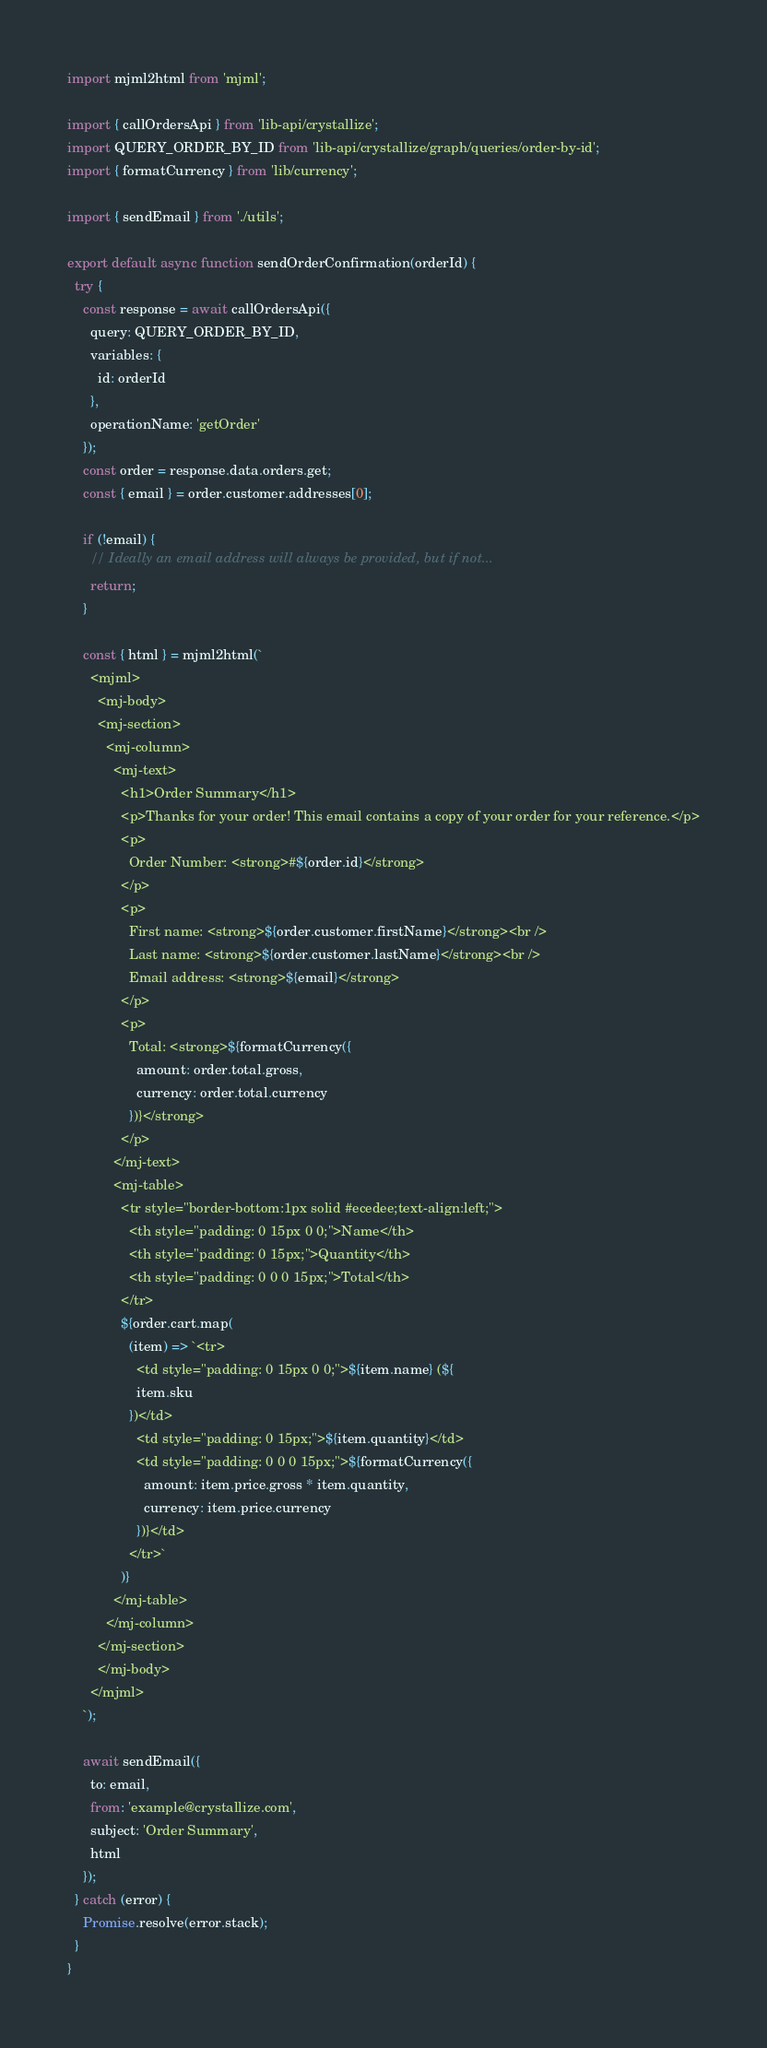Convert code to text. <code><loc_0><loc_0><loc_500><loc_500><_JavaScript_>import mjml2html from 'mjml';

import { callOrdersApi } from 'lib-api/crystallize';
import QUERY_ORDER_BY_ID from 'lib-api/crystallize/graph/queries/order-by-id';
import { formatCurrency } from 'lib/currency';

import { sendEmail } from './utils';

export default async function sendOrderConfirmation(orderId) {
  try {
    const response = await callOrdersApi({
      query: QUERY_ORDER_BY_ID,
      variables: {
        id: orderId
      },
      operationName: 'getOrder'
    });
    const order = response.data.orders.get;
    const { email } = order.customer.addresses[0];

    if (!email) {
      // Ideally an email address will always be provided, but if not...
      return;
    }

    const { html } = mjml2html(`
      <mjml>
        <mj-body>
        <mj-section>
          <mj-column>
            <mj-text>
              <h1>Order Summary</h1>
              <p>Thanks for your order! This email contains a copy of your order for your reference.</p>
              <p>
                Order Number: <strong>#${order.id}</strong>
              </p>
              <p>
                First name: <strong>${order.customer.firstName}</strong><br />
                Last name: <strong>${order.customer.lastName}</strong><br />
                Email address: <strong>${email}</strong>
              </p>
              <p>
                Total: <strong>${formatCurrency({
                  amount: order.total.gross,
                  currency: order.total.currency
                })}</strong>
              </p>
            </mj-text>
            <mj-table>
              <tr style="border-bottom:1px solid #ecedee;text-align:left;">
                <th style="padding: 0 15px 0 0;">Name</th>
                <th style="padding: 0 15px;">Quantity</th>
                <th style="padding: 0 0 0 15px;">Total</th>
              </tr>
              ${order.cart.map(
                (item) => `<tr>
                  <td style="padding: 0 15px 0 0;">${item.name} (${
                  item.sku
                })</td>
                  <td style="padding: 0 15px;">${item.quantity}</td>
                  <td style="padding: 0 0 0 15px;">${formatCurrency({
                    amount: item.price.gross * item.quantity,
                    currency: item.price.currency
                  })}</td>
                </tr>`
              )}
            </mj-table>
          </mj-column>
        </mj-section>
        </mj-body>
      </mjml>
    `);

    await sendEmail({
      to: email,
      from: 'example@crystallize.com',
      subject: 'Order Summary',
      html
    });
  } catch (error) {
    Promise.resolve(error.stack);
  }
}
</code> 